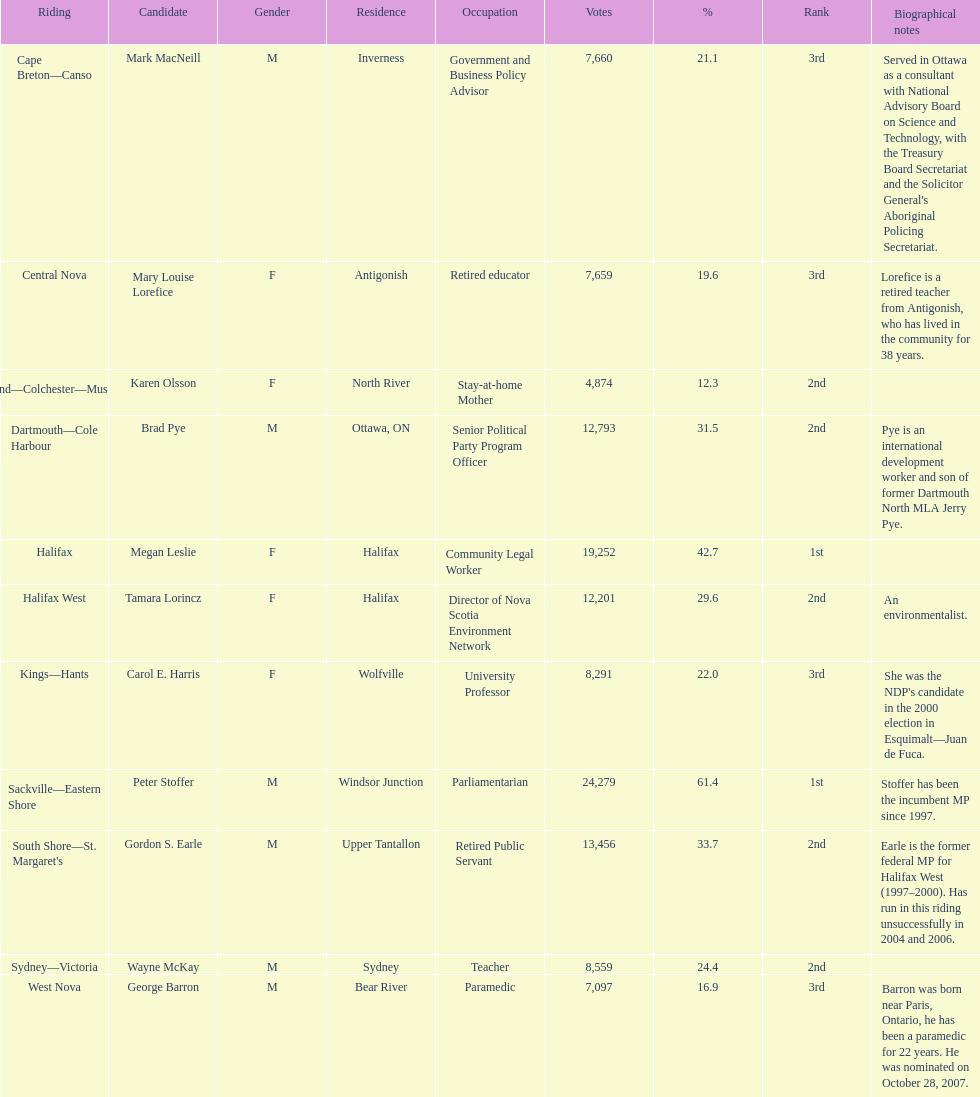How many individuals from halifax participated as candidates? 2. 